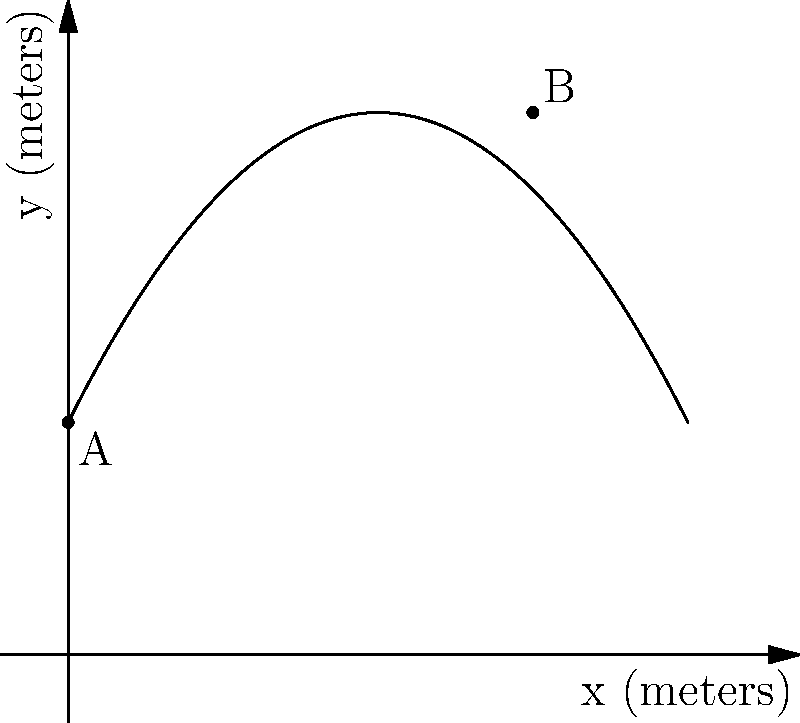During a match at Suncorp Stadium, you kick a soccer ball from point A $(0,3)$ to point B $(6,7)$. Assuming the ball's trajectory follows a parabolic path described by the equation $y = ax^2 + bx + c$, what is the maximum height reached by the ball? To find the maximum height of the ball's trajectory, we need to follow these steps:

1) First, we need to find the equation of the parabola. We know it passes through points A $(0,3)$ and B $(6,7)$, and it has the general form $y = ax^2 + bx + c$.

2) Using point A $(0,3)$, we can determine that $c = 3$.

3) We can set up two equations using points A and B:
   $3 = a(0)^2 + b(0) + 3$
   $7 = a(6)^2 + b(6) + 3$

4) Simplifying the second equation:
   $4 = 36a + 6b$

5) We need one more equation. We can use the fact that the axis of symmetry of the parabola is halfway between the x-coordinates of A and B, at $x = 3$. The formula for the axis of symmetry is $x = -b/(2a)$, so:
   $3 = -b/(2a)$

6) Solving these equations simultaneously:
   $b = -6a$
   $4 = 36a + 6(-6a) = 0$
   $a = -1/9$
   $b = 2/3$

7) So the equation of the parabola is:
   $y = -\frac{1}{9}x^2 + \frac{2}{3}x + 3$

8) The maximum height occurs at the vertex of the parabola. The x-coordinate of the vertex is at the axis of symmetry, $x = 3$.

9) To find the y-coordinate (maximum height), we substitute $x = 3$ into our equation:
   $y = -\frac{1}{9}(3)^2 + \frac{2}{3}(3) + 3$
   $y = -1 + 2 + 3 = 4$

Therefore, the maximum height reached by the ball is 4 meters.
Answer: 4 meters 